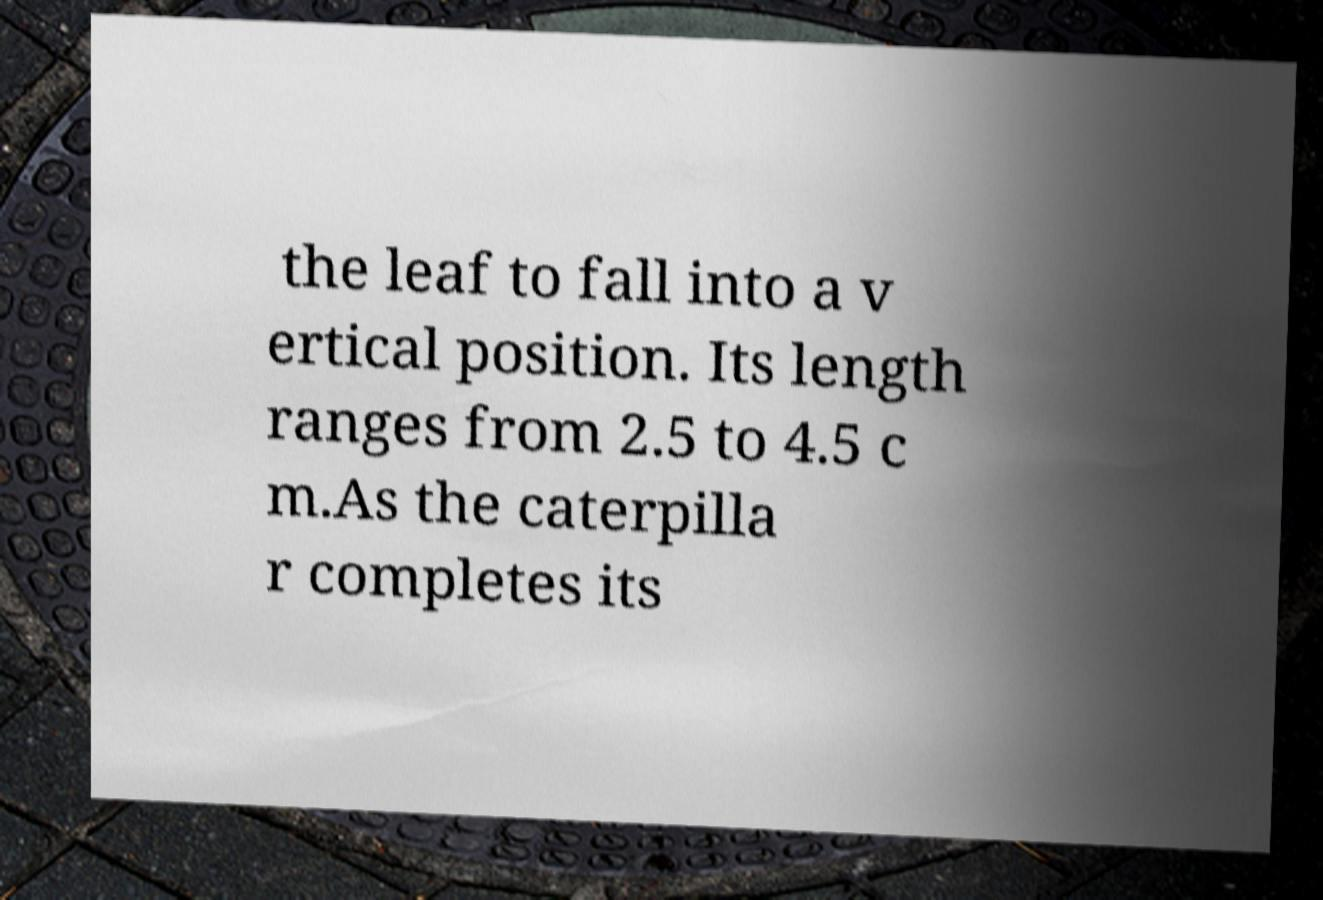There's text embedded in this image that I need extracted. Can you transcribe it verbatim? the leaf to fall into a v ertical position. Its length ranges from 2.5 to 4.5 c m.As the caterpilla r completes its 